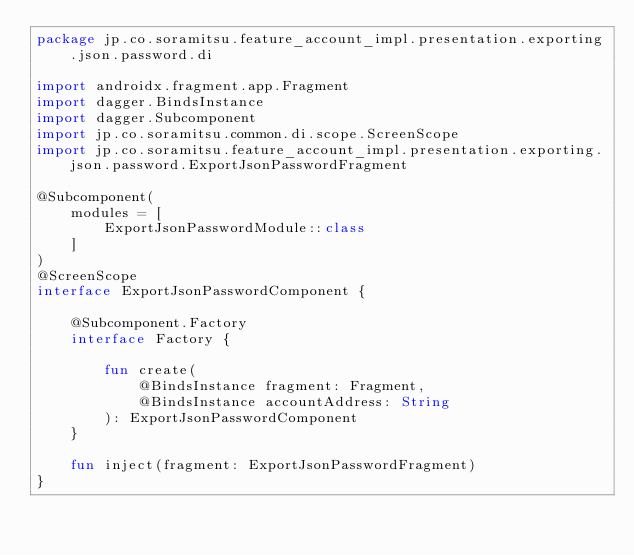Convert code to text. <code><loc_0><loc_0><loc_500><loc_500><_Kotlin_>package jp.co.soramitsu.feature_account_impl.presentation.exporting.json.password.di

import androidx.fragment.app.Fragment
import dagger.BindsInstance
import dagger.Subcomponent
import jp.co.soramitsu.common.di.scope.ScreenScope
import jp.co.soramitsu.feature_account_impl.presentation.exporting.json.password.ExportJsonPasswordFragment

@Subcomponent(
    modules = [
        ExportJsonPasswordModule::class
    ]
)
@ScreenScope
interface ExportJsonPasswordComponent {

    @Subcomponent.Factory
    interface Factory {

        fun create(
            @BindsInstance fragment: Fragment,
            @BindsInstance accountAddress: String
        ): ExportJsonPasswordComponent
    }

    fun inject(fragment: ExportJsonPasswordFragment)
}</code> 